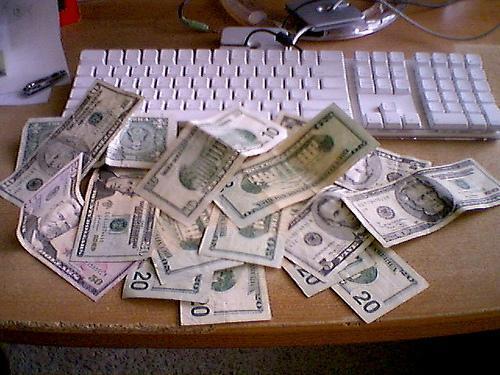How many 5 dollar bills are visible?
Give a very brief answer. 1. 